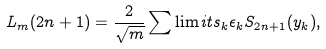<formula> <loc_0><loc_0><loc_500><loc_500>L _ { m } ( 2 n + 1 ) = \frac { 2 } { \sqrt { m } } \sum \lim i t s _ { k } \epsilon _ { k } S _ { 2 n + 1 } ( y _ { k } ) ,</formula> 